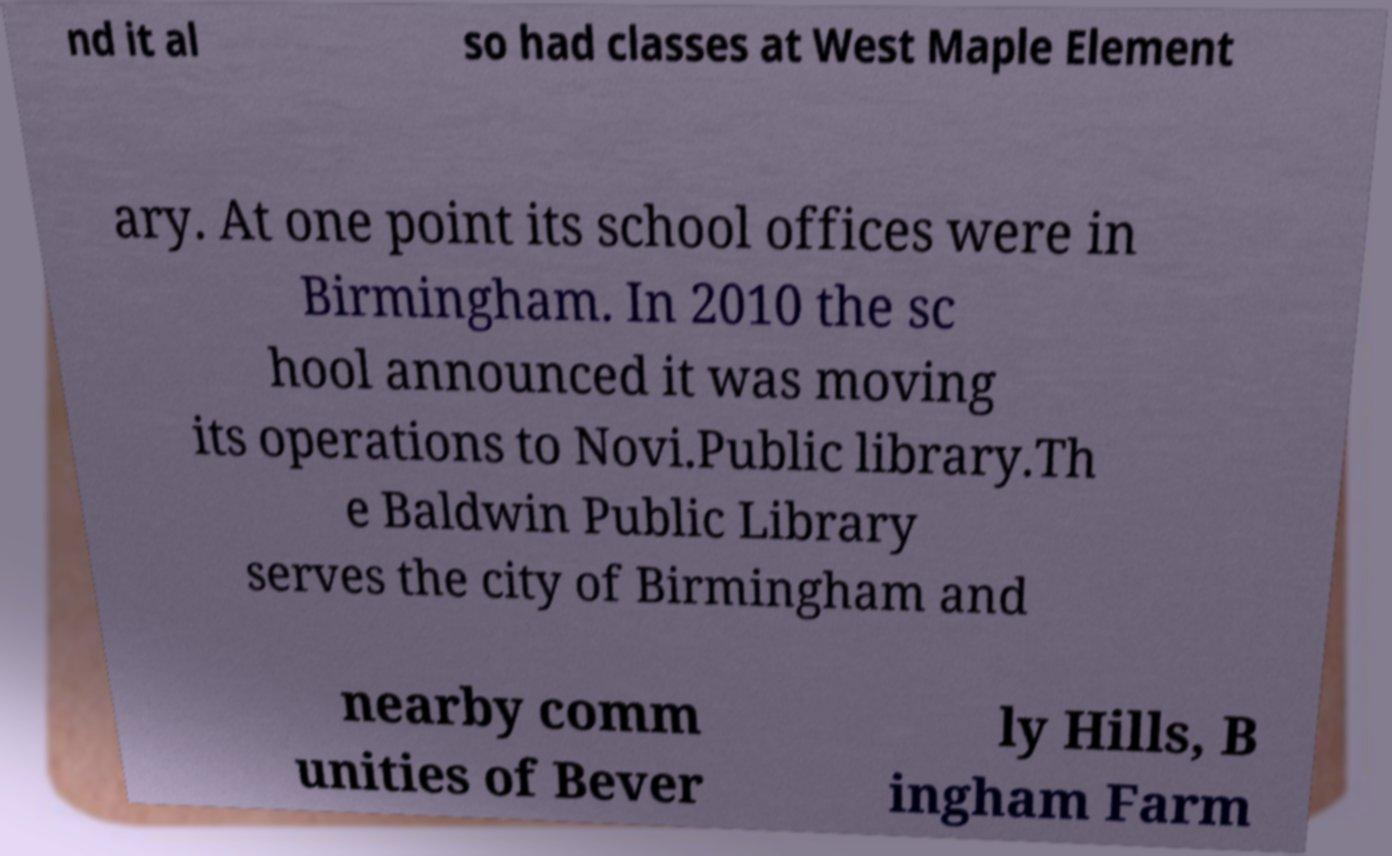What messages or text are displayed in this image? I need them in a readable, typed format. nd it al so had classes at West Maple Element ary. At one point its school offices were in Birmingham. In 2010 the sc hool announced it was moving its operations to Novi.Public library.Th e Baldwin Public Library serves the city of Birmingham and nearby comm unities of Bever ly Hills, B ingham Farm 